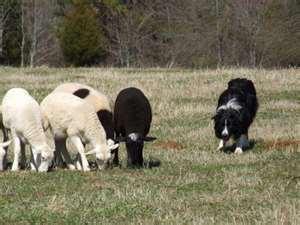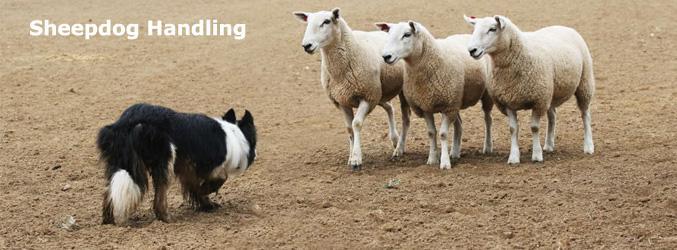The first image is the image on the left, the second image is the image on the right. Evaluate the accuracy of this statement regarding the images: "There are more sheep in the image on the left.". Is it true? Answer yes or no. Yes. The first image is the image on the left, the second image is the image on the right. For the images displayed, is the sentence "One image shows a dog to the right of sheep, and the other shows a dog to the left of sheep." factually correct? Answer yes or no. Yes. 